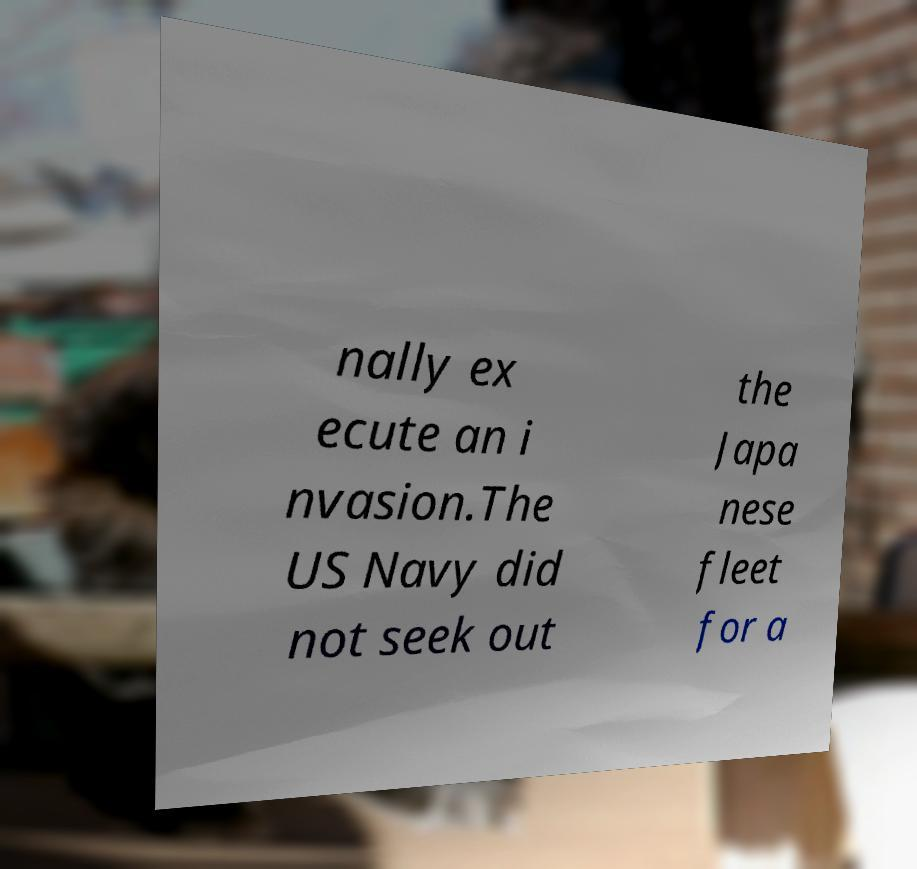Could you extract and type out the text from this image? nally ex ecute an i nvasion.The US Navy did not seek out the Japa nese fleet for a 